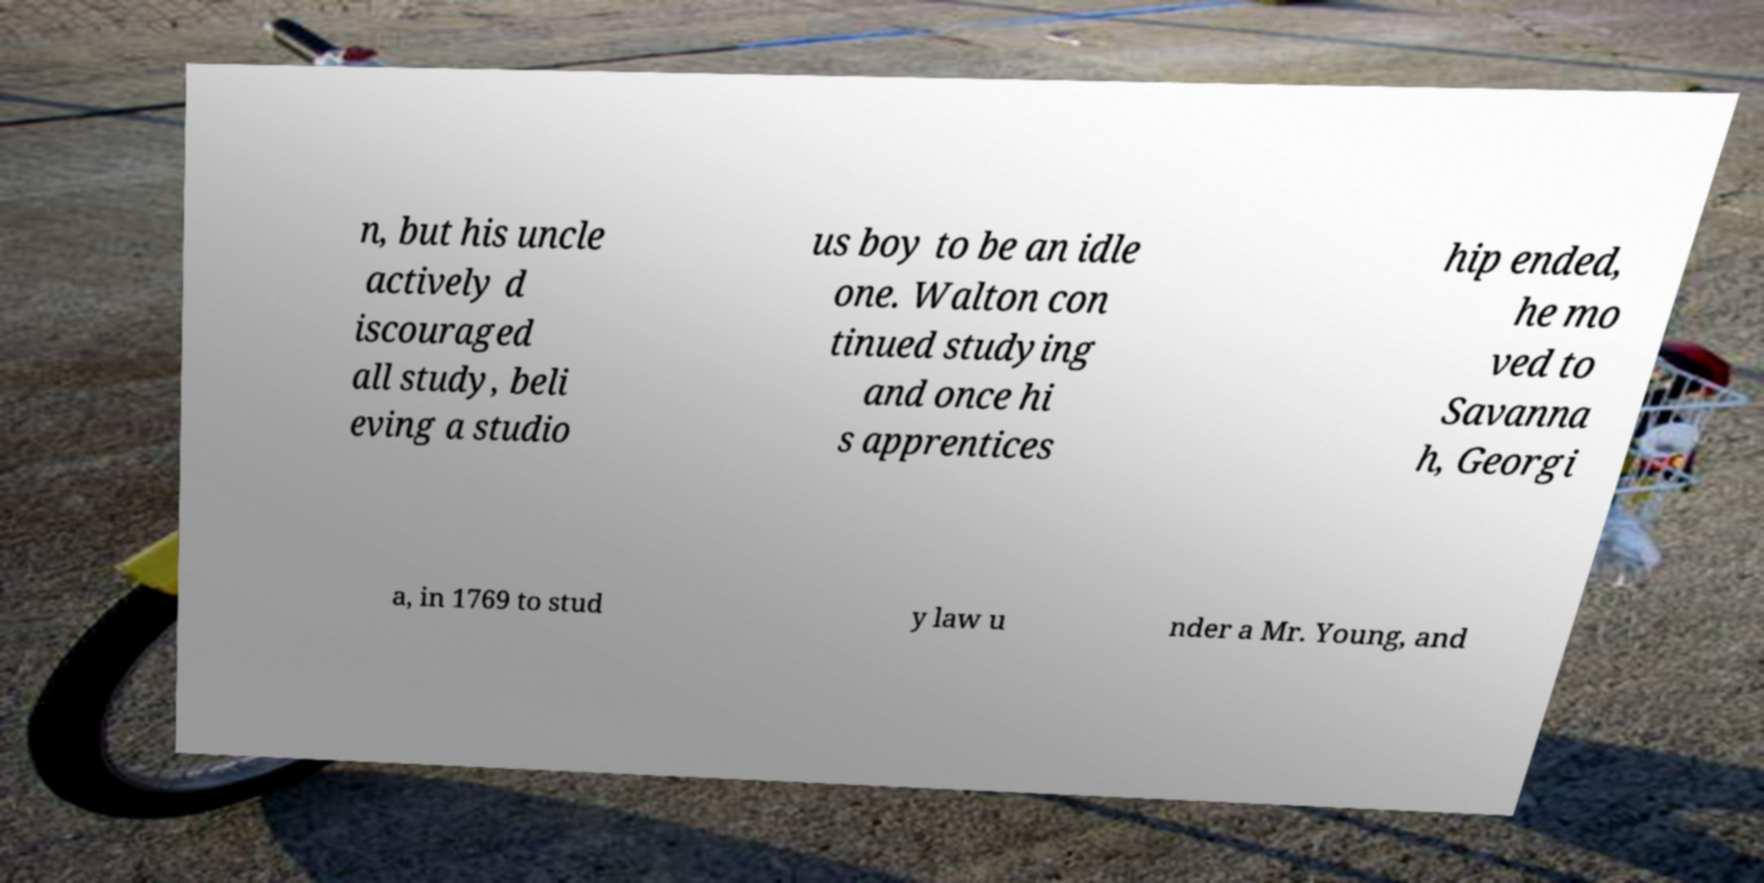There's text embedded in this image that I need extracted. Can you transcribe it verbatim? n, but his uncle actively d iscouraged all study, beli eving a studio us boy to be an idle one. Walton con tinued studying and once hi s apprentices hip ended, he mo ved to Savanna h, Georgi a, in 1769 to stud y law u nder a Mr. Young, and 